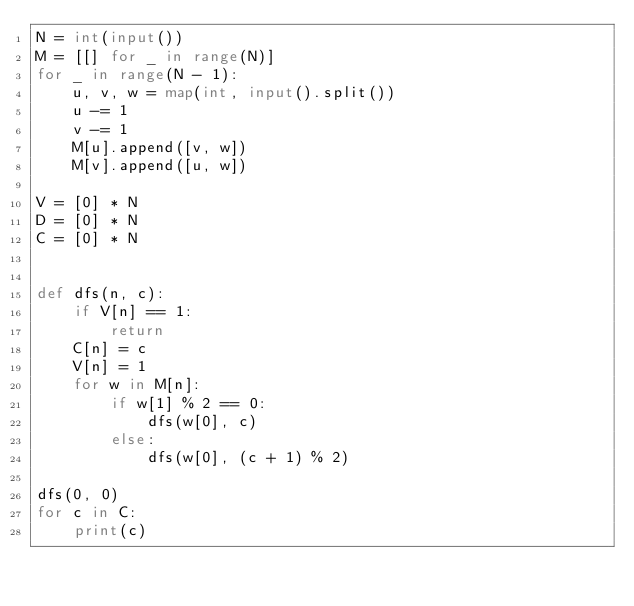<code> <loc_0><loc_0><loc_500><loc_500><_Python_>N = int(input())
M = [[] for _ in range(N)]
for _ in range(N - 1):
    u, v, w = map(int, input().split())
    u -= 1
    v -= 1
    M[u].append([v, w])
    M[v].append([u, w])

V = [0] * N
D = [0] * N
C = [0] * N


def dfs(n, c):
    if V[n] == 1:
        return
    C[n] = c
    V[n] = 1
    for w in M[n]:
        if w[1] % 2 == 0:
            dfs(w[0], c)
        else:
            dfs(w[0], (c + 1) % 2)

dfs(0, 0)
for c in C:
    print(c)
</code> 